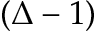<formula> <loc_0><loc_0><loc_500><loc_500>( \Delta - 1 )</formula> 